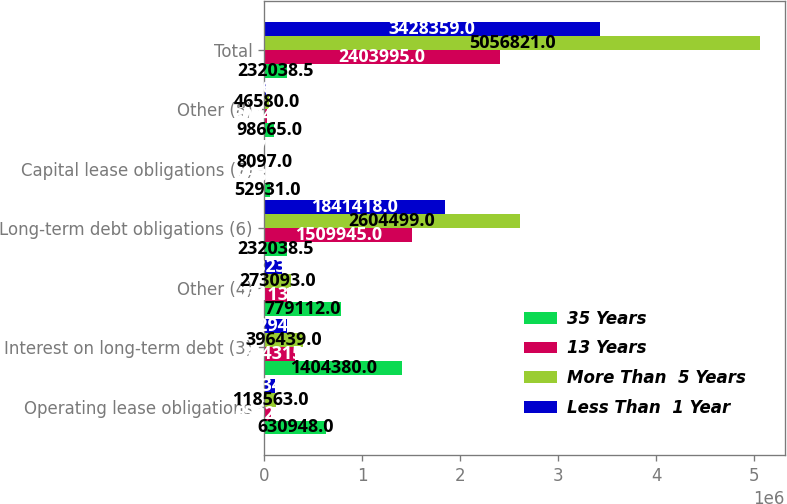Convert chart. <chart><loc_0><loc_0><loc_500><loc_500><stacked_bar_chart><ecel><fcel>Operating lease obligations<fcel>Interest on long-term debt (3)<fcel>Other (4)<fcel>Long-term debt obligations (6)<fcel>Capital lease obligations (7)<fcel>Other (8)<fcel>Total<nl><fcel>35 Years<fcel>630948<fcel>1.40438e+06<fcel>779112<fcel>232038<fcel>52931<fcel>98665<fcel>232038<nl><fcel>13 Years<fcel>65929<fcel>314315<fcel>231137<fcel>1.50994e+06<fcel>9538<fcel>30740<fcel>2.404e+06<nl><fcel>More Than  5 Years<fcel>118563<fcel>396439<fcel>273093<fcel>2.6045e+06<fcel>8097<fcel>46580<fcel>5.05682e+06<nl><fcel>Less Than  1 Year<fcel>108343<fcel>232940<fcel>178234<fcel>1.84142e+06<fcel>4875<fcel>17664<fcel>3.42836e+06<nl></chart> 